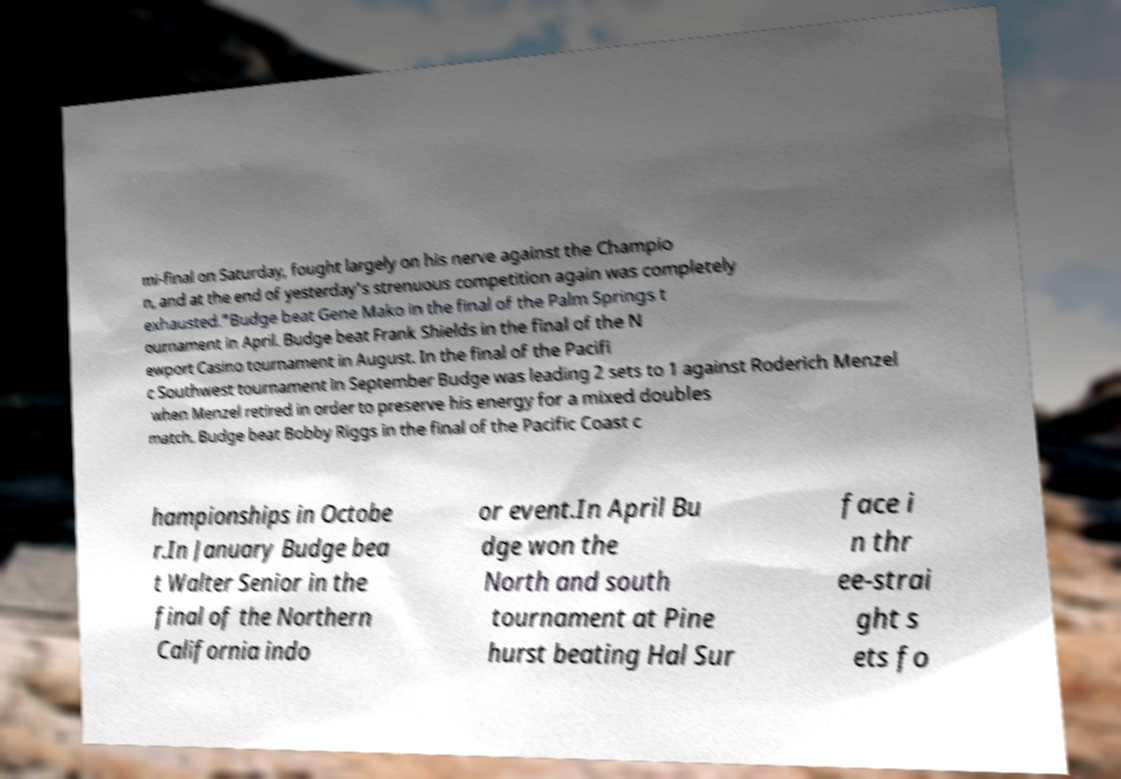There's text embedded in this image that I need extracted. Can you transcribe it verbatim? mi-final on Saturday, fought largely on his nerve against the Champio n, and at the end of yesterday's strenuous competition again was completely exhausted."Budge beat Gene Mako in the final of the Palm Springs t ournament in April. Budge beat Frank Shields in the final of the N ewport Casino tournament in August. In the final of the Pacifi c Southwest tournament in September Budge was leading 2 sets to 1 against Roderich Menzel when Menzel retired in order to preserve his energy for a mixed doubles match. Budge beat Bobby Riggs in the final of the Pacific Coast c hampionships in Octobe r.In January Budge bea t Walter Senior in the final of the Northern California indo or event.In April Bu dge won the North and south tournament at Pine hurst beating Hal Sur face i n thr ee-strai ght s ets fo 